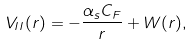Convert formula to latex. <formula><loc_0><loc_0><loc_500><loc_500>V _ { I I } ( r ) = - \frac { \alpha _ { s } C _ { F } } r + W ( r ) ,</formula> 